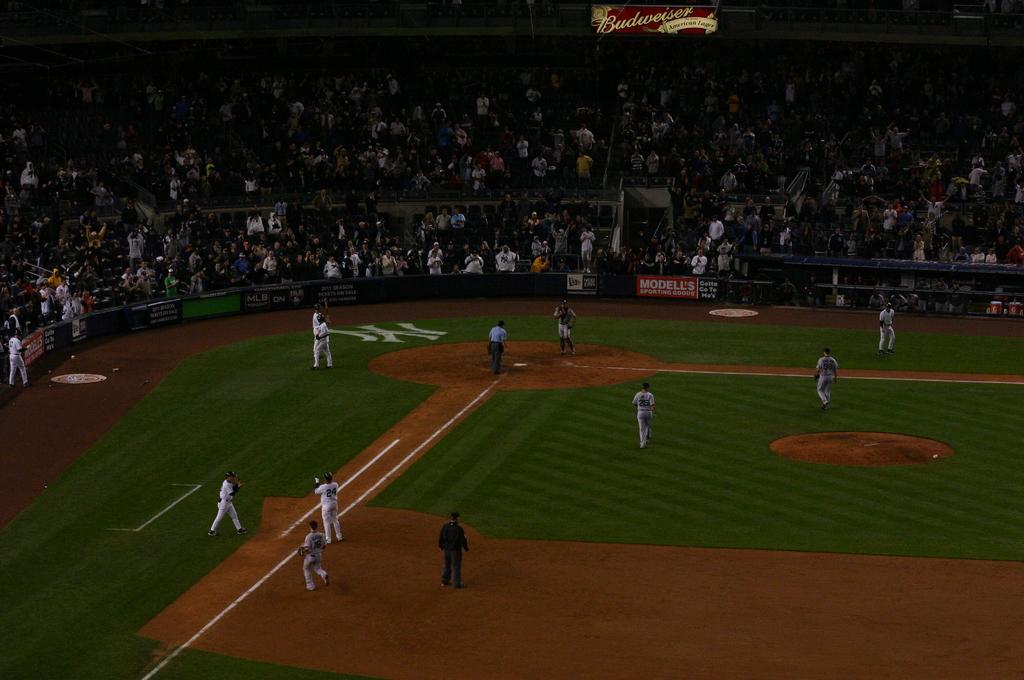What beer company is sponsoring the yankees?
Offer a terse response. Budweiser. What logo is displayed on the field?
Offer a terse response. Ny. 